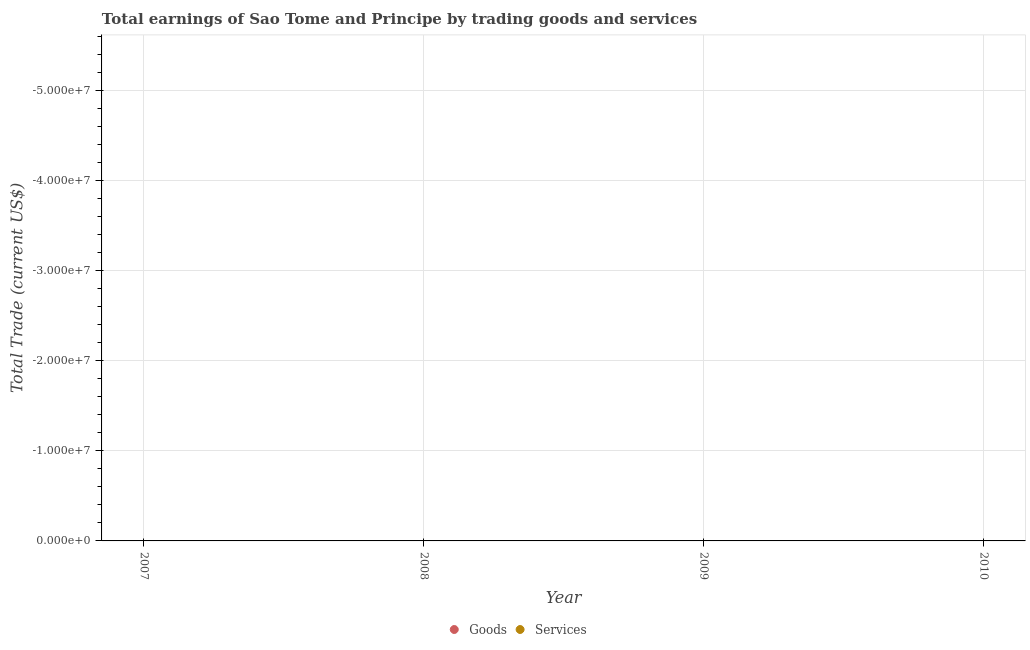How many different coloured dotlines are there?
Give a very brief answer. 0. Is the number of dotlines equal to the number of legend labels?
Offer a very short reply. No. What is the amount earned by trading goods in 2009?
Keep it short and to the point. 0. Across all years, what is the minimum amount earned by trading services?
Ensure brevity in your answer.  0. What is the total amount earned by trading services in the graph?
Your answer should be compact. 0. In how many years, is the amount earned by trading goods greater than -46000000 US$?
Make the answer very short. 0. In how many years, is the amount earned by trading goods greater than the average amount earned by trading goods taken over all years?
Make the answer very short. 0. Does the amount earned by trading services monotonically increase over the years?
Your answer should be compact. No. What is the difference between two consecutive major ticks on the Y-axis?
Provide a succinct answer. 1.00e+07. Does the graph contain any zero values?
Your answer should be very brief. Yes. Does the graph contain grids?
Offer a very short reply. Yes. Where does the legend appear in the graph?
Offer a very short reply. Bottom center. What is the title of the graph?
Offer a very short reply. Total earnings of Sao Tome and Principe by trading goods and services. What is the label or title of the Y-axis?
Keep it short and to the point. Total Trade (current US$). What is the Total Trade (current US$) in Goods in 2007?
Provide a short and direct response. 0. What is the Total Trade (current US$) in Services in 2007?
Provide a succinct answer. 0. What is the Total Trade (current US$) of Services in 2009?
Make the answer very short. 0. What is the average Total Trade (current US$) of Goods per year?
Offer a very short reply. 0. 